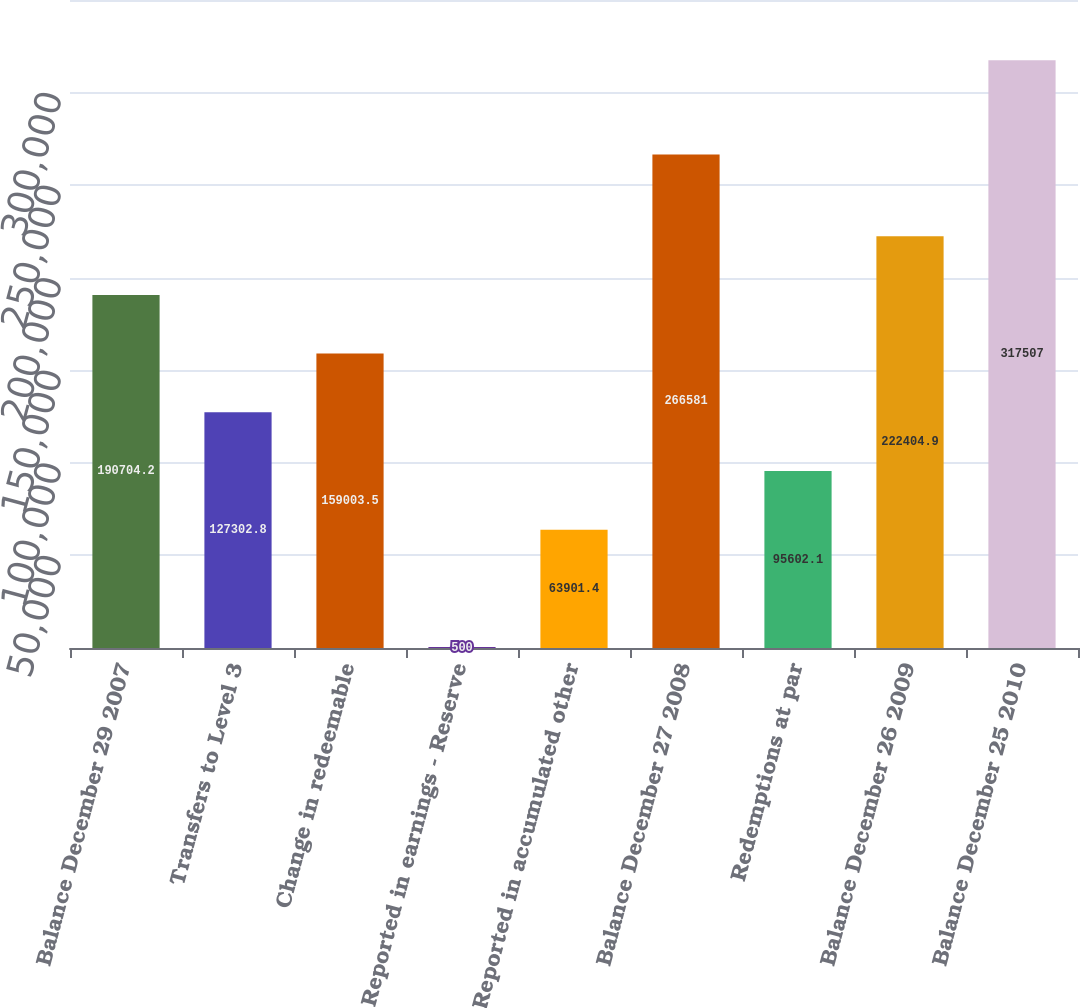Convert chart to OTSL. <chart><loc_0><loc_0><loc_500><loc_500><bar_chart><fcel>Balance December 29 2007<fcel>Transfers to Level 3<fcel>Change in redeemable<fcel>Reported in earnings - Reserve<fcel>Reported in accumulated other<fcel>Balance December 27 2008<fcel>Redemptions at par<fcel>Balance December 26 2009<fcel>Balance December 25 2010<nl><fcel>190704<fcel>127303<fcel>159004<fcel>500<fcel>63901.4<fcel>266581<fcel>95602.1<fcel>222405<fcel>317507<nl></chart> 